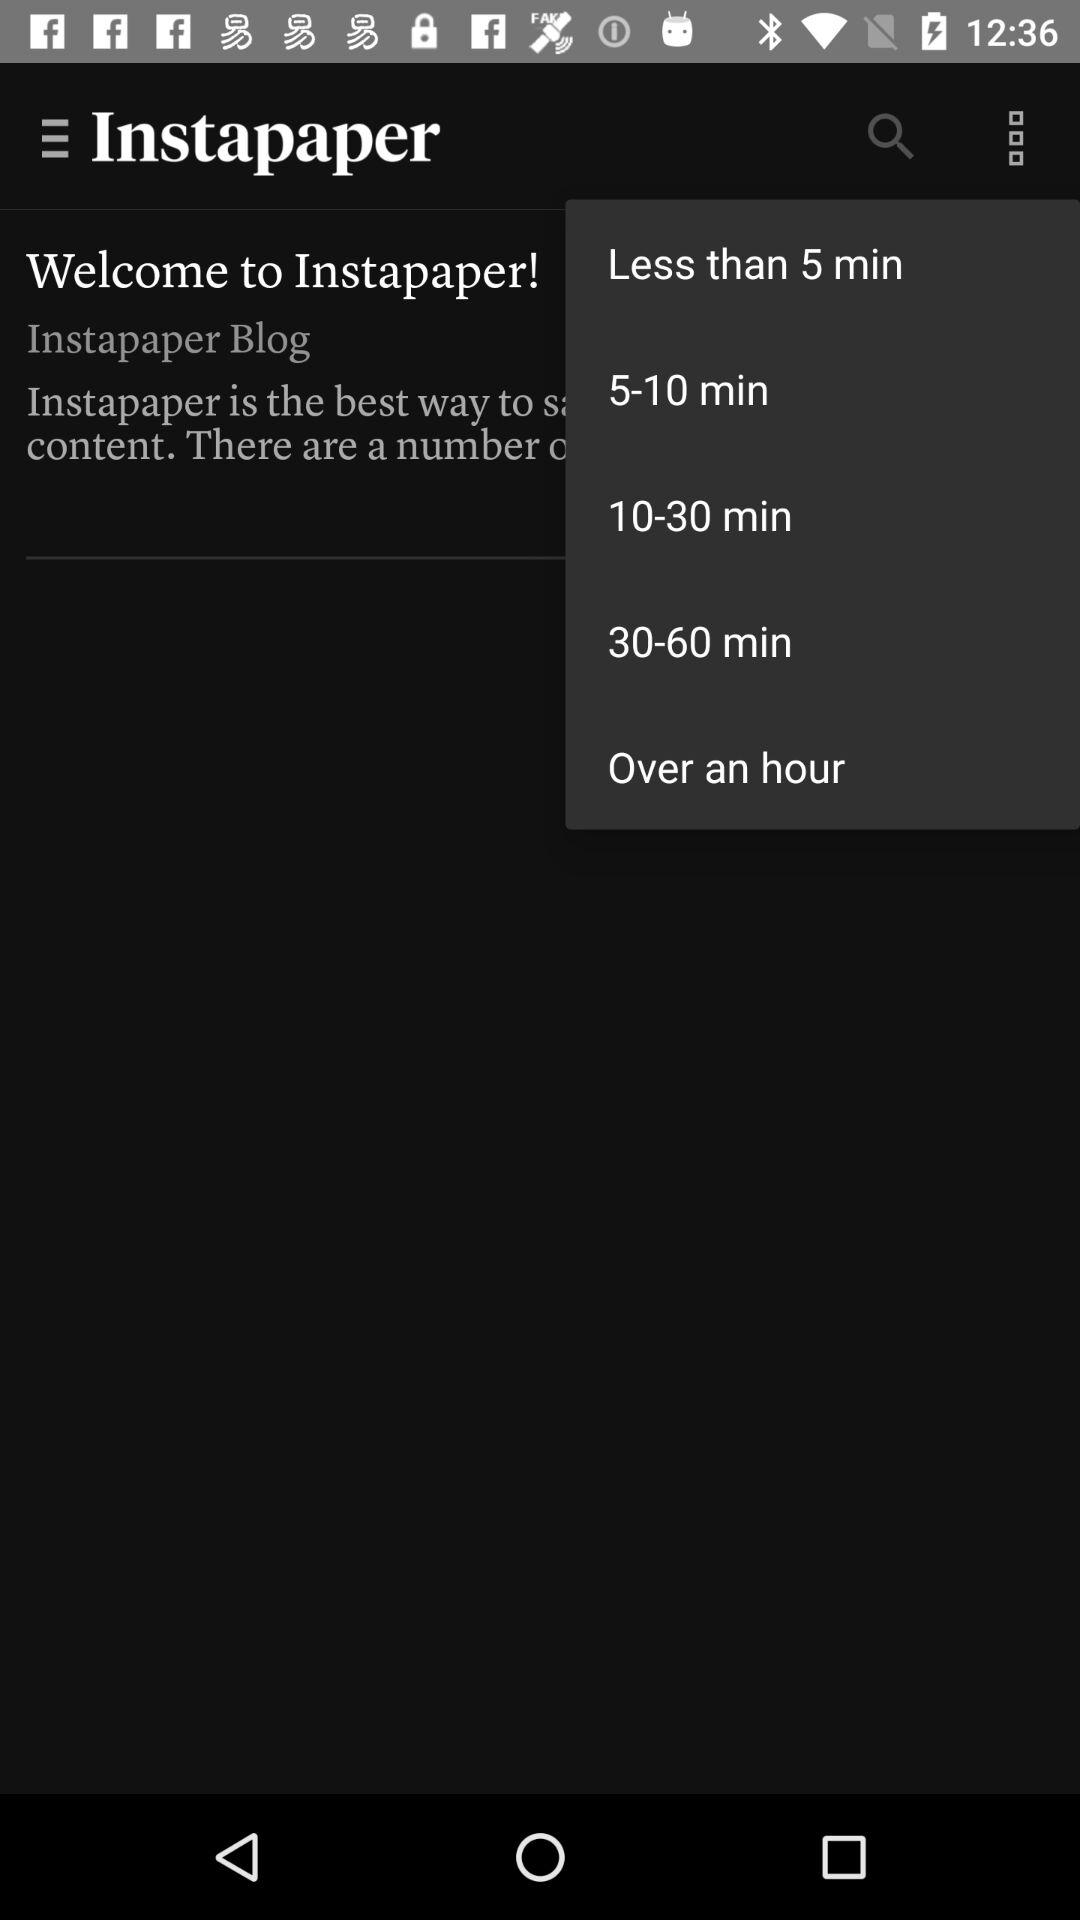What is the description of "Instapaper"?
When the provided information is insufficient, respond with <no answer>. <no answer> 